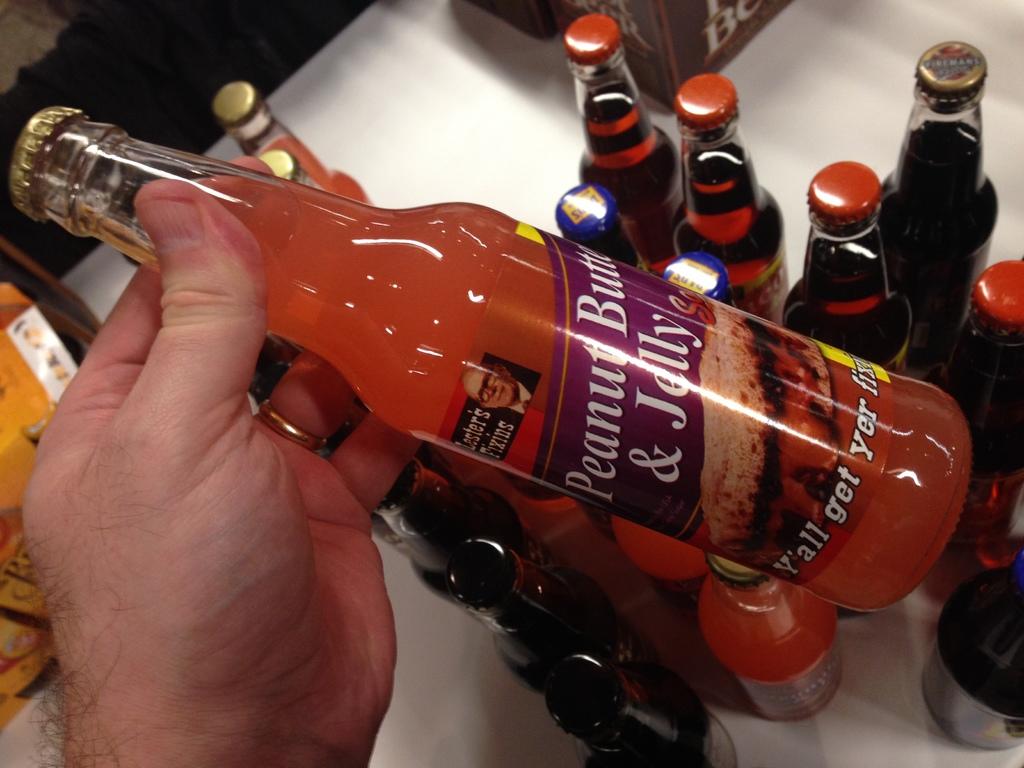What flavor is the drink the person is holding?
Ensure brevity in your answer.  Peanut butter & jelly. Is y'all written on the bottle?
Offer a terse response. Yes. 